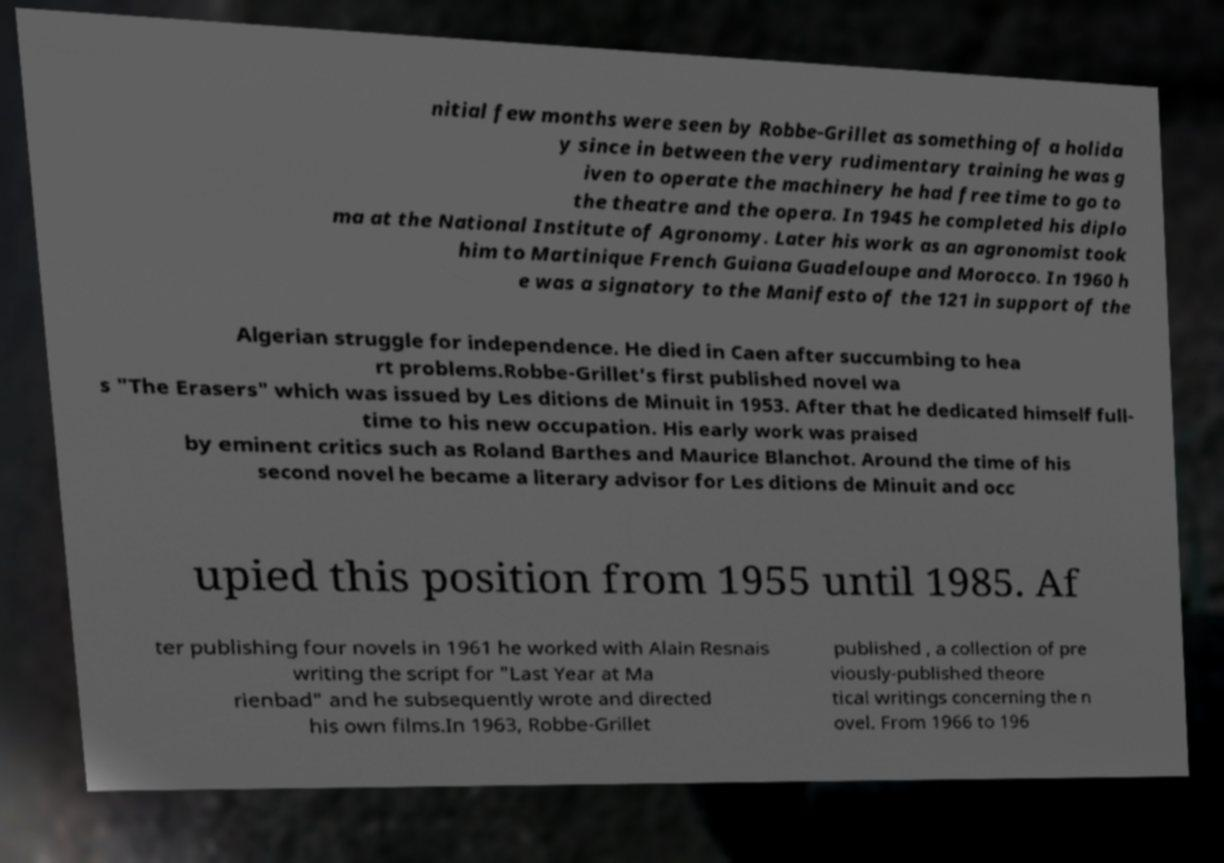Could you assist in decoding the text presented in this image and type it out clearly? nitial few months were seen by Robbe-Grillet as something of a holida y since in between the very rudimentary training he was g iven to operate the machinery he had free time to go to the theatre and the opera. In 1945 he completed his diplo ma at the National Institute of Agronomy. Later his work as an agronomist took him to Martinique French Guiana Guadeloupe and Morocco. In 1960 h e was a signatory to the Manifesto of the 121 in support of the Algerian struggle for independence. He died in Caen after succumbing to hea rt problems.Robbe-Grillet's first published novel wa s "The Erasers" which was issued by Les ditions de Minuit in 1953. After that he dedicated himself full- time to his new occupation. His early work was praised by eminent critics such as Roland Barthes and Maurice Blanchot. Around the time of his second novel he became a literary advisor for Les ditions de Minuit and occ upied this position from 1955 until 1985. Af ter publishing four novels in 1961 he worked with Alain Resnais writing the script for "Last Year at Ma rienbad" and he subsequently wrote and directed his own films.In 1963, Robbe-Grillet published , a collection of pre viously-published theore tical writings concerning the n ovel. From 1966 to 196 